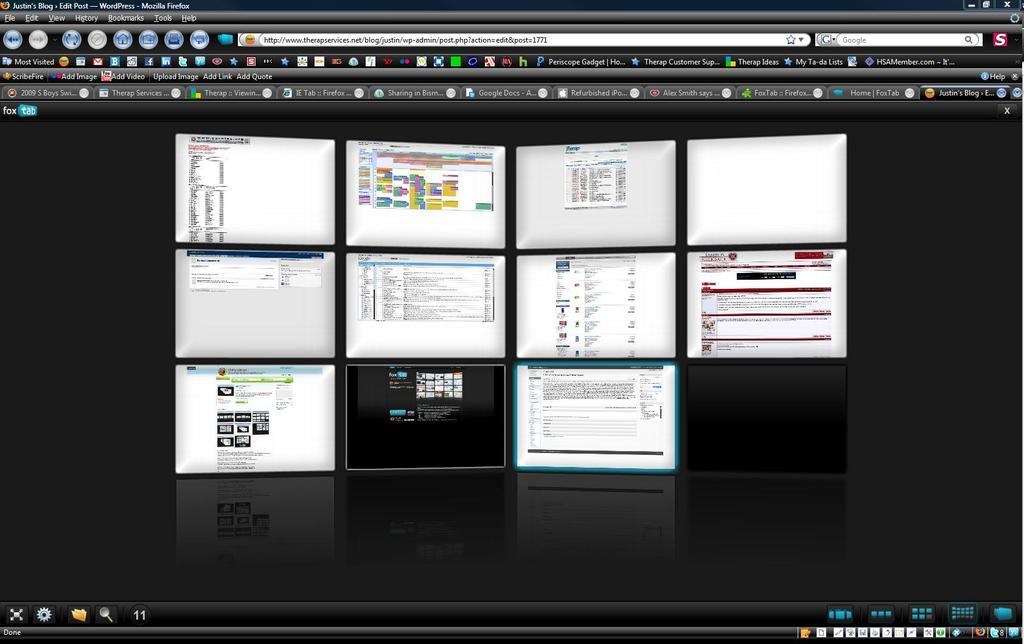<image>
Relay a brief, clear account of the picture shown. an open computer screen that says 'most visited' on one of the buttons 